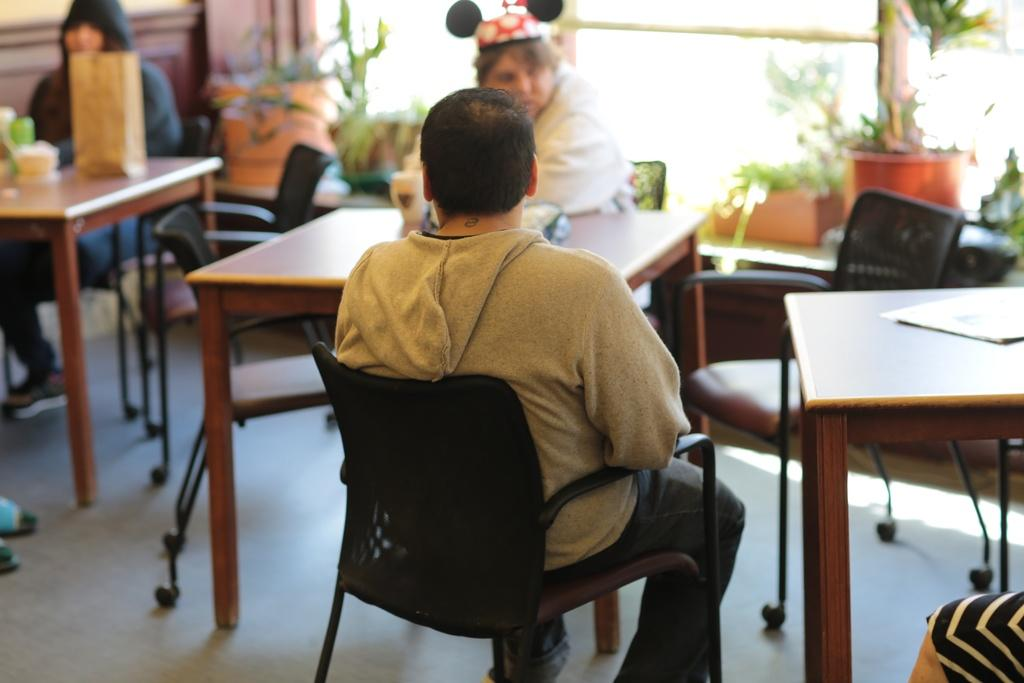How many people are sitting in the image? There are three persons sitting on chairs in the image. What can be seen on the tables in the image? There are objects on tables visible in the image. What type of furniture is present in the image? Chairs are visible in the image. What part of the room can be seen in the image? The floor is visible in the image. What type of vegetation is present in the background of the image? There are house plants in the background of the image. What type of tent can be seen in the image? There is no tent present in the image. How many railway tracks are visible in the image? There are no railway tracks visible in the image. 